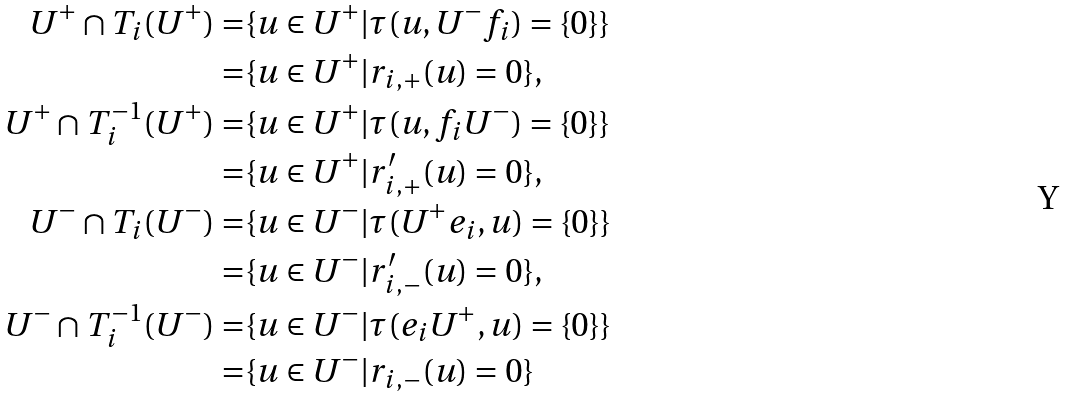<formula> <loc_0><loc_0><loc_500><loc_500>U ^ { + } \cap T _ { i } ( U ^ { + } ) = & \{ u \in U ^ { + } | \tau ( u , U ^ { - } f _ { i } ) = \{ 0 \} \} \\ = & \{ u \in U ^ { + } | r _ { i , + } ( u ) = 0 \} , \\ U ^ { + } \cap T _ { i } ^ { - 1 } ( U ^ { + } ) = & \{ u \in U ^ { + } | \tau ( u , f _ { i } U ^ { - } ) = \{ 0 \} \} \\ = & \{ u \in U ^ { + } | r ^ { \prime } _ { i , + } ( u ) = 0 \} , \\ U ^ { - } \cap T _ { i } ( U ^ { - } ) = & \{ u \in U ^ { - } | \tau ( U ^ { + } e _ { i } , u ) = \{ 0 \} \} \\ = & \{ u \in U ^ { - } | r ^ { \prime } _ { i , - } ( u ) = 0 \} , \\ U ^ { - } \cap T _ { i } ^ { - 1 } ( U ^ { - } ) = & \{ u \in U ^ { - } | \tau ( e _ { i } U ^ { + } , u ) = \{ 0 \} \} \\ = & \{ u \in U ^ { - } | r _ { i , - } ( u ) = 0 \}</formula> 